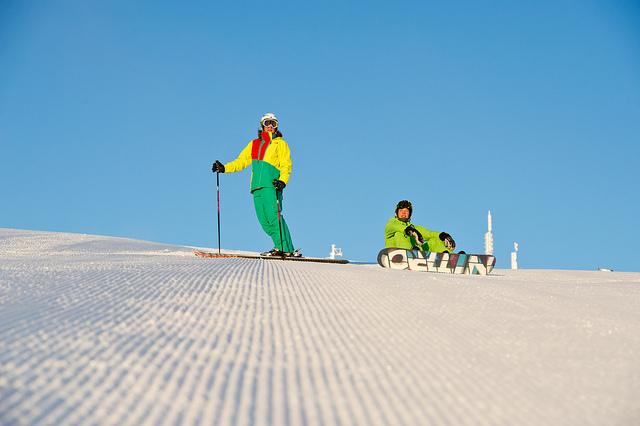What could the condition of the terrain be described as? Please explain your reasoning. groomed. The snow on the ground is perfectly tended to for uniformity. 